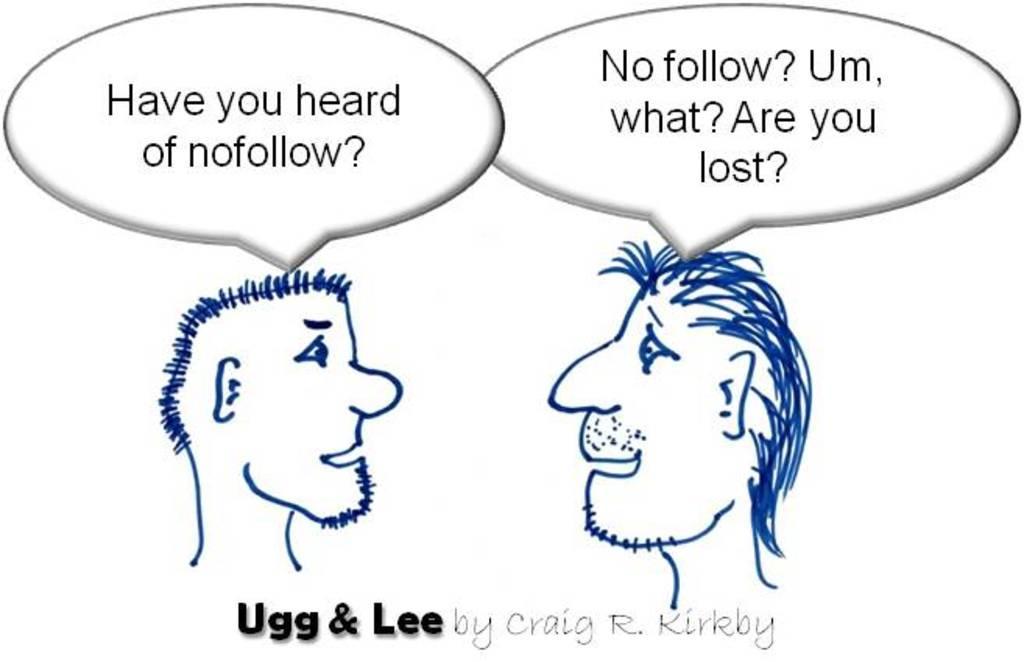Could you give a brief overview of what you see in this image? In this picture we can observe a sketch of two persons. We can observe some words in this picture. The background is in white color. 